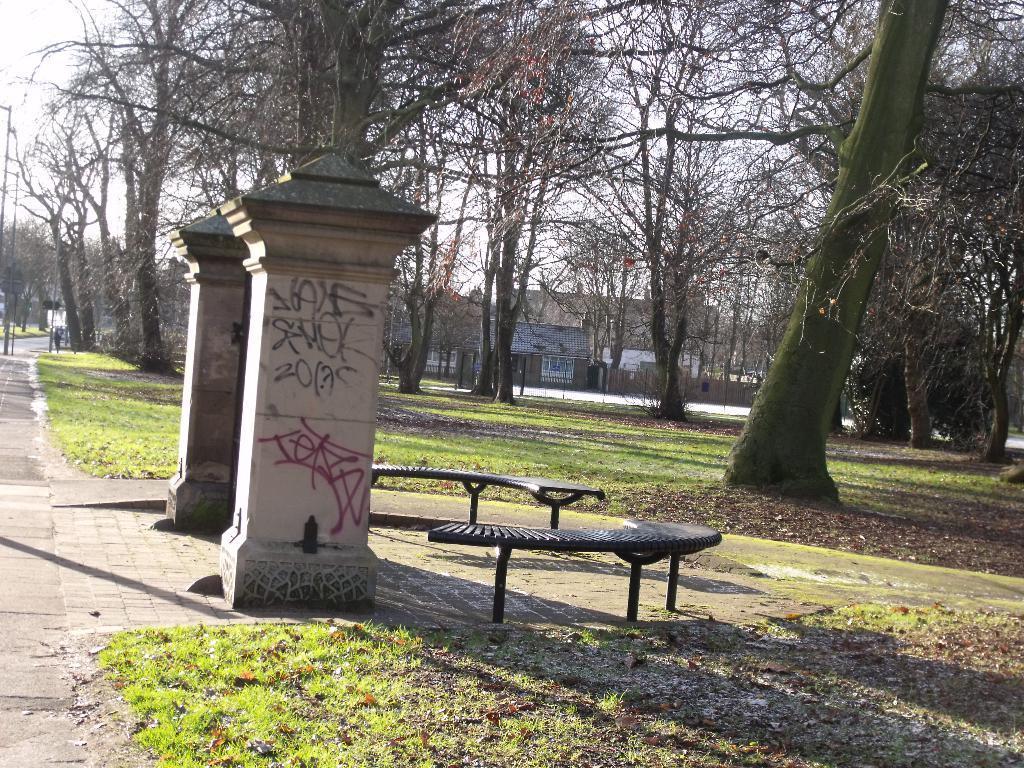Describe this image in one or two sentences. As we can see in the image there are trees, buildings, grass, benches and sky. 